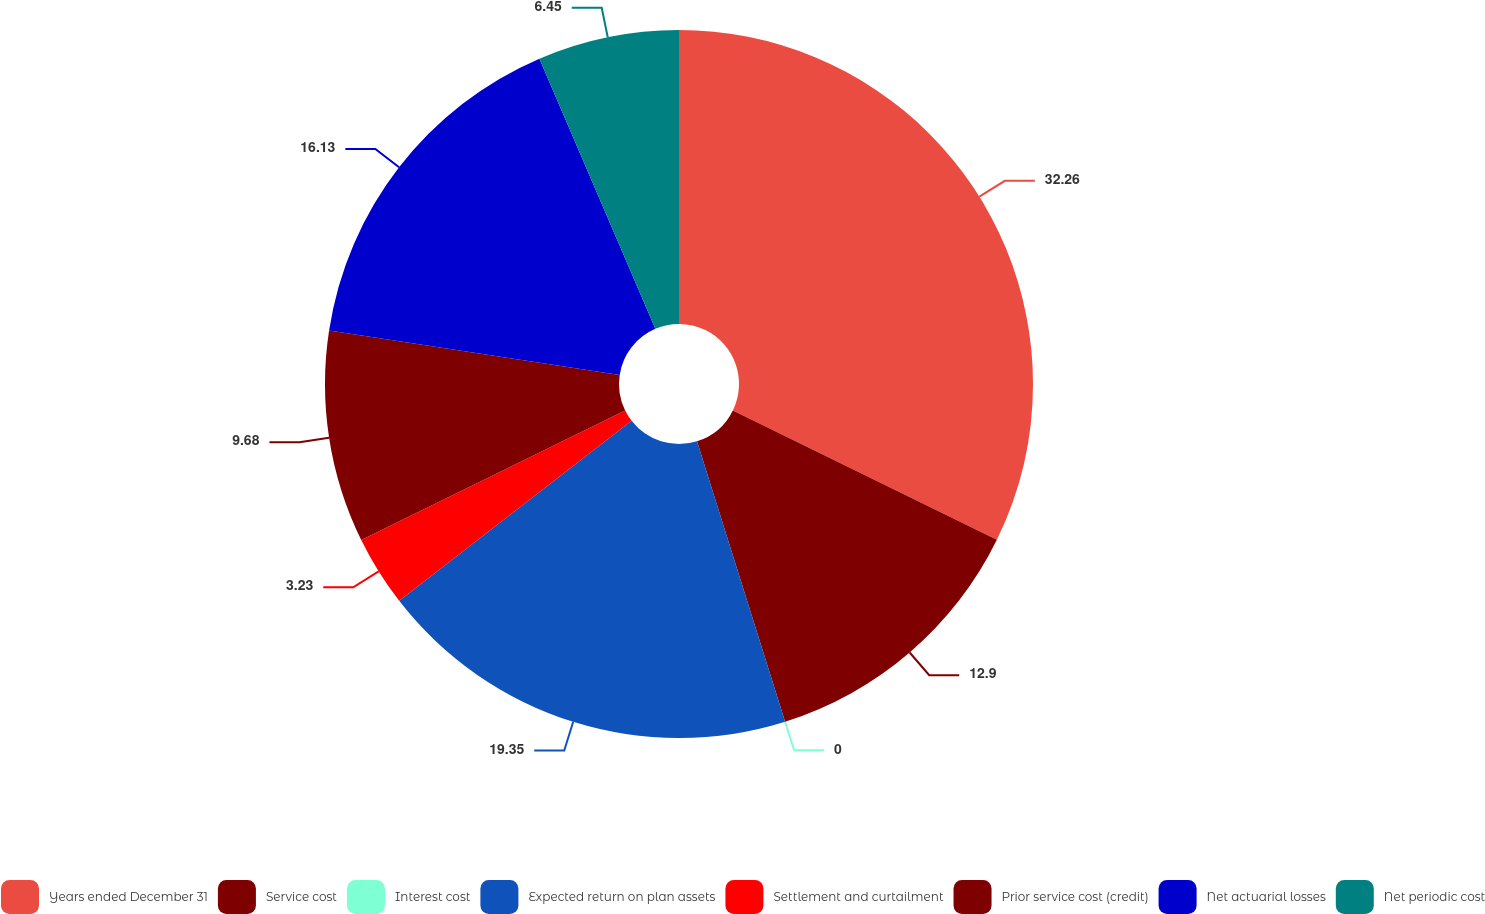Convert chart. <chart><loc_0><loc_0><loc_500><loc_500><pie_chart><fcel>Years ended December 31<fcel>Service cost<fcel>Interest cost<fcel>Expected return on plan assets<fcel>Settlement and curtailment<fcel>Prior service cost (credit)<fcel>Net actuarial losses<fcel>Net periodic cost<nl><fcel>32.25%<fcel>12.9%<fcel>0.0%<fcel>19.35%<fcel>3.23%<fcel>9.68%<fcel>16.13%<fcel>6.45%<nl></chart> 